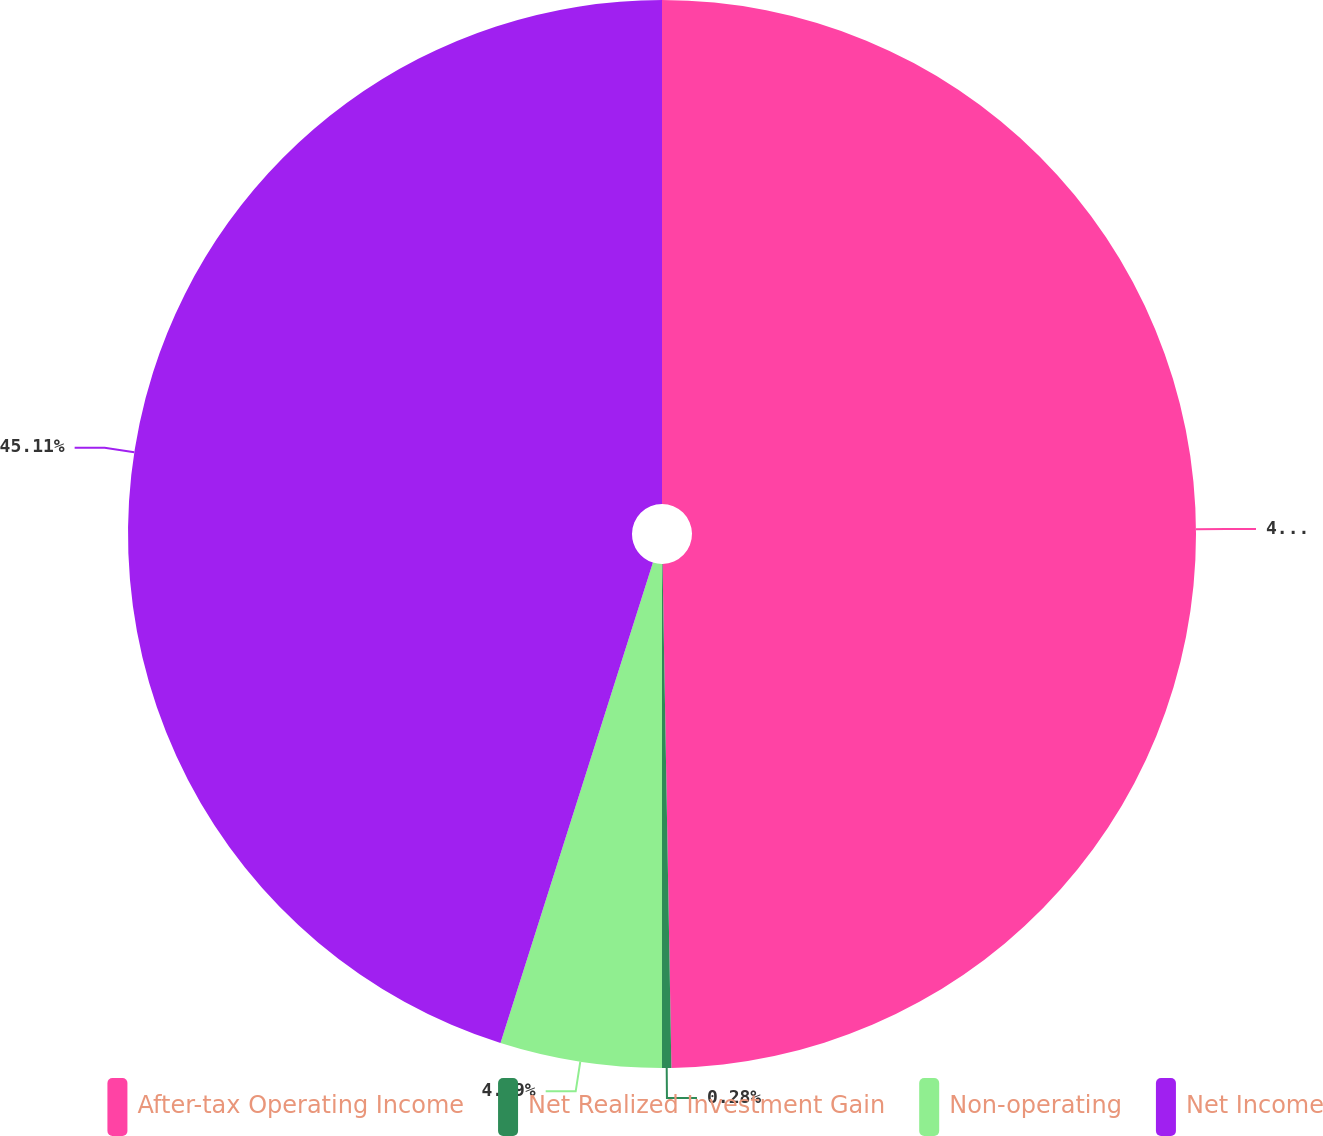Convert chart. <chart><loc_0><loc_0><loc_500><loc_500><pie_chart><fcel>After-tax Operating Income<fcel>Net Realized Investment Gain<fcel>Non-operating<fcel>Net Income<nl><fcel>49.72%<fcel>0.28%<fcel>4.89%<fcel>45.11%<nl></chart> 